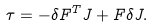Convert formula to latex. <formula><loc_0><loc_0><loc_500><loc_500>\tau = - \delta F ^ { T } J + F \delta J .</formula> 